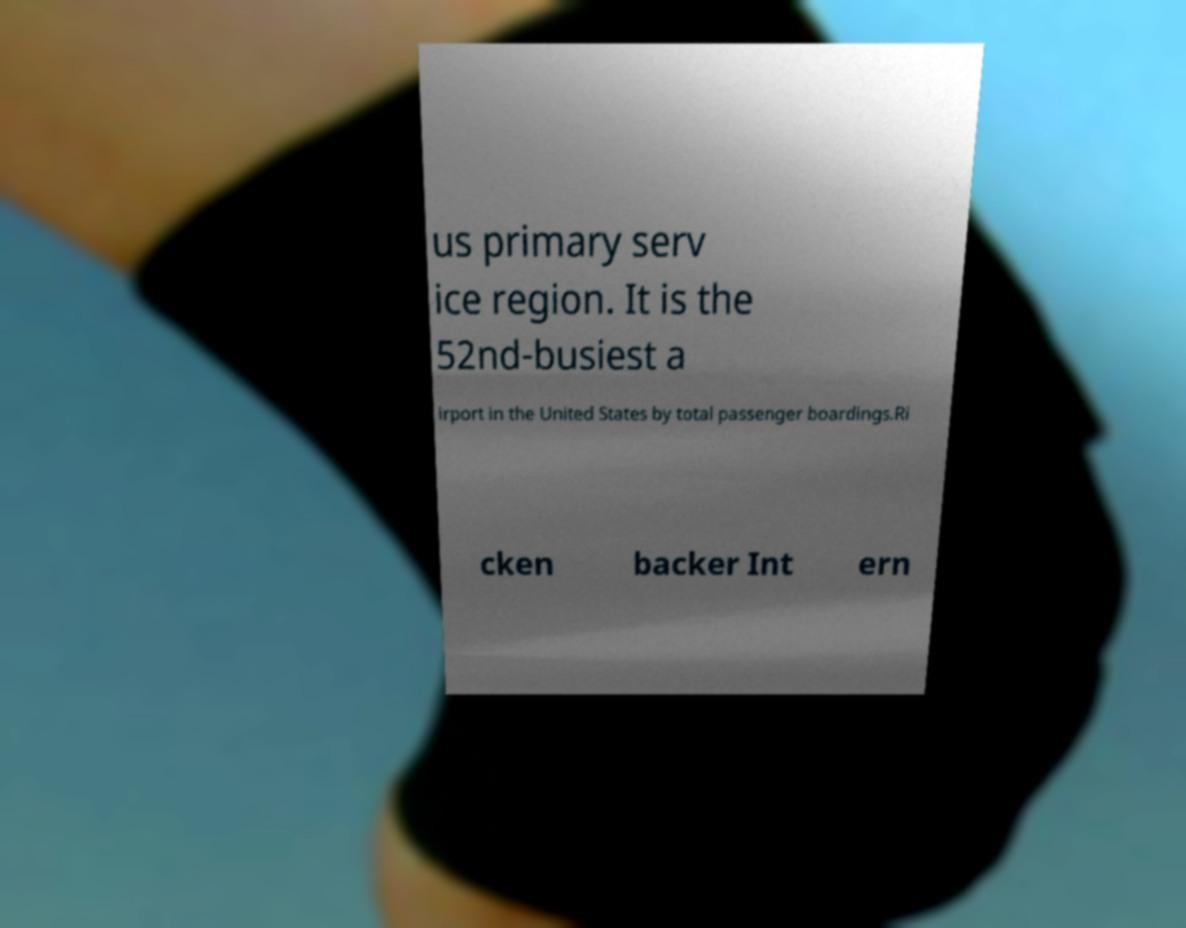Can you accurately transcribe the text from the provided image for me? us primary serv ice region. It is the 52nd-busiest a irport in the United States by total passenger boardings.Ri cken backer Int ern 